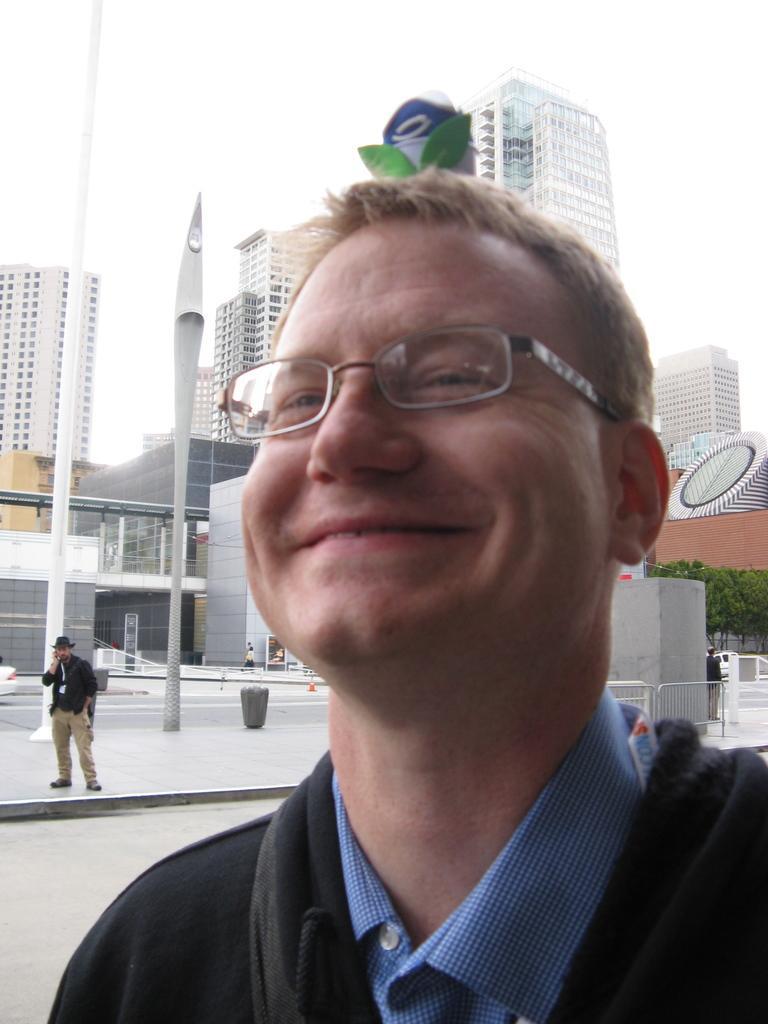Can you describe this image briefly? In this image there is a person with a smile on his face, behind the person there are buildings and trees, in front of the buildings there is another person standing. 